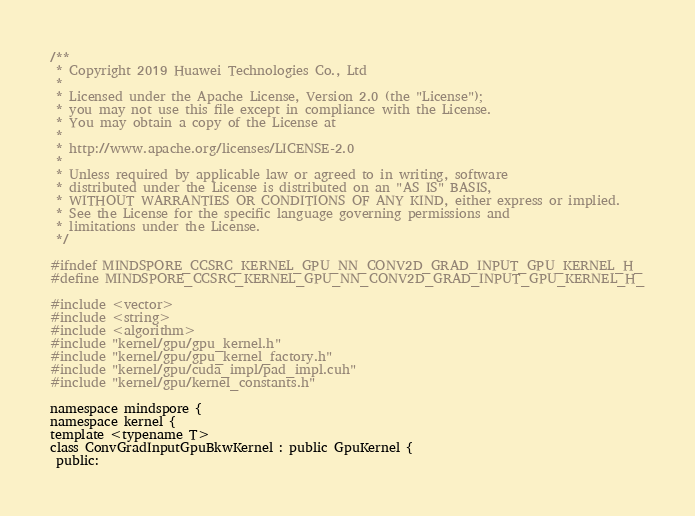Convert code to text. <code><loc_0><loc_0><loc_500><loc_500><_C_>/**
 * Copyright 2019 Huawei Technologies Co., Ltd
 *
 * Licensed under the Apache License, Version 2.0 (the "License");
 * you may not use this file except in compliance with the License.
 * You may obtain a copy of the License at
 *
 * http://www.apache.org/licenses/LICENSE-2.0
 *
 * Unless required by applicable law or agreed to in writing, software
 * distributed under the License is distributed on an "AS IS" BASIS,
 * WITHOUT WARRANTIES OR CONDITIONS OF ANY KIND, either express or implied.
 * See the License for the specific language governing permissions and
 * limitations under the License.
 */

#ifndef MINDSPORE_CCSRC_KERNEL_GPU_NN_CONV2D_GRAD_INPUT_GPU_KERNEL_H_
#define MINDSPORE_CCSRC_KERNEL_GPU_NN_CONV2D_GRAD_INPUT_GPU_KERNEL_H_

#include <vector>
#include <string>
#include <algorithm>
#include "kernel/gpu/gpu_kernel.h"
#include "kernel/gpu/gpu_kernel_factory.h"
#include "kernel/gpu/cuda_impl/pad_impl.cuh"
#include "kernel/gpu/kernel_constants.h"

namespace mindspore {
namespace kernel {
template <typename T>
class ConvGradInputGpuBkwKernel : public GpuKernel {
 public:</code> 